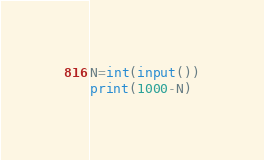<code> <loc_0><loc_0><loc_500><loc_500><_Python_>N=int(input())
print(1000-N)</code> 